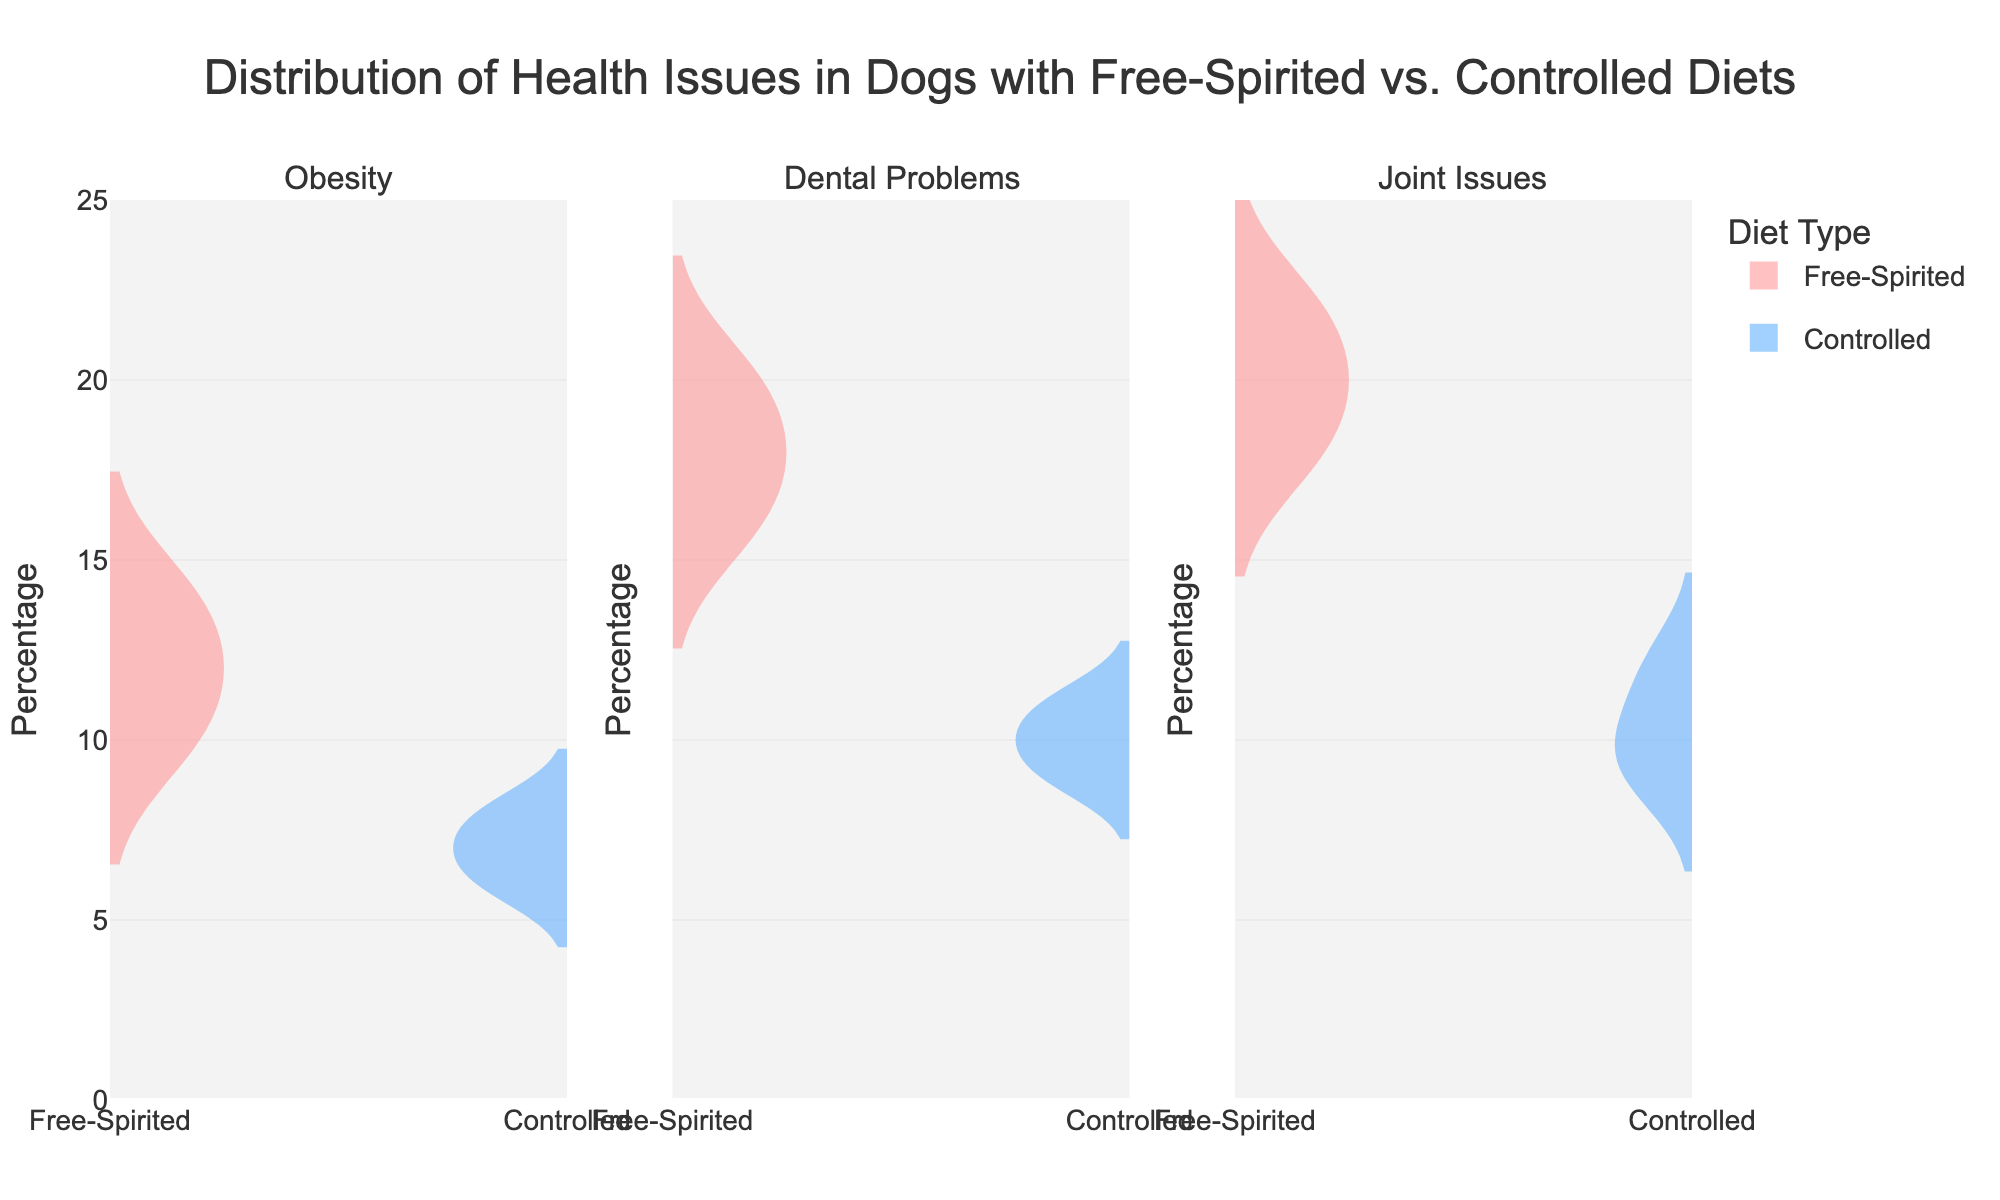What is the title of the figure? The title of the figure is displayed at the top center. It reads "Distribution of Health Issues in Dogs with Free-Spirited vs. Controlled Diets."
Answer: Distribution of Health Issues in Dogs with Free-Spirited vs. Controlled Diets What are the colors used to represent the different diet types? The colors used to represent the diet types are pinkish-red for the Free-Spirited diet and blue for the Controlled diet.
Answer: Pinkish-red and blue How many subplots are there in the figure? The figure contains three subplots corresponding to the three health issues: Obesity, Dental Problems, and Joint Issues.
Answer: Three What is the maximum value on the y-axis? The maximum value on the y-axis is 25, as indicated by the range and tick marks.
Answer: 25 What is the range of percentages for the Controlled diet in the Joint Issues subplot? The range for percentages is determined by finding the minimum and maximum values within the Controlled diet for Joint Issues. The minimum is 9 and the maximum is 12.
Answer: 9 to 12 What is the average percentage of Dental Problems across both diet types? Calculate the average of the given percentages: Free-Spirited (18, 16, 20) and Controlled (9, 11, 10). Free-Spirited: (18+16+20)/3 = 18. Controlled: (9+11+10)/3 = 10. Avg: (18+10)/2 = 14.
Answer: 14 Which diet type has a higher median percentage of Joint Issues? Calculate the median for Joint Issues for both diet types. Free-Spirited: 20, 22, 18 has a median of 20. Controlled: 10, 12, 9 has a median of 10.
Answer: Free-Spirited For Obesity, which diet type shows a greater spread in percentages? Compare the range of percentages for Obesity: Free-Spirited (10 to 14 with a range of 4) and Controlled (6 to 8 with a range of 2). The Free-Spirited diet type shows a greater spread.
Answer: Free-Spirited In which health issue do the two diet types show the most overlap in their distributions? Observe the overlapping areas of the violin plots for each health issue. Joint Issues show the most overlap in their distributions between the two diet types.
Answer: Joint Issues Do any of the health issues show a unique distribution shape for any diet type? Examine the shapes of the violin plots for distinctive patterns. Dental Problems in the Free-Spirited diet type shows a wider distribution.
Answer: Dental Problems 